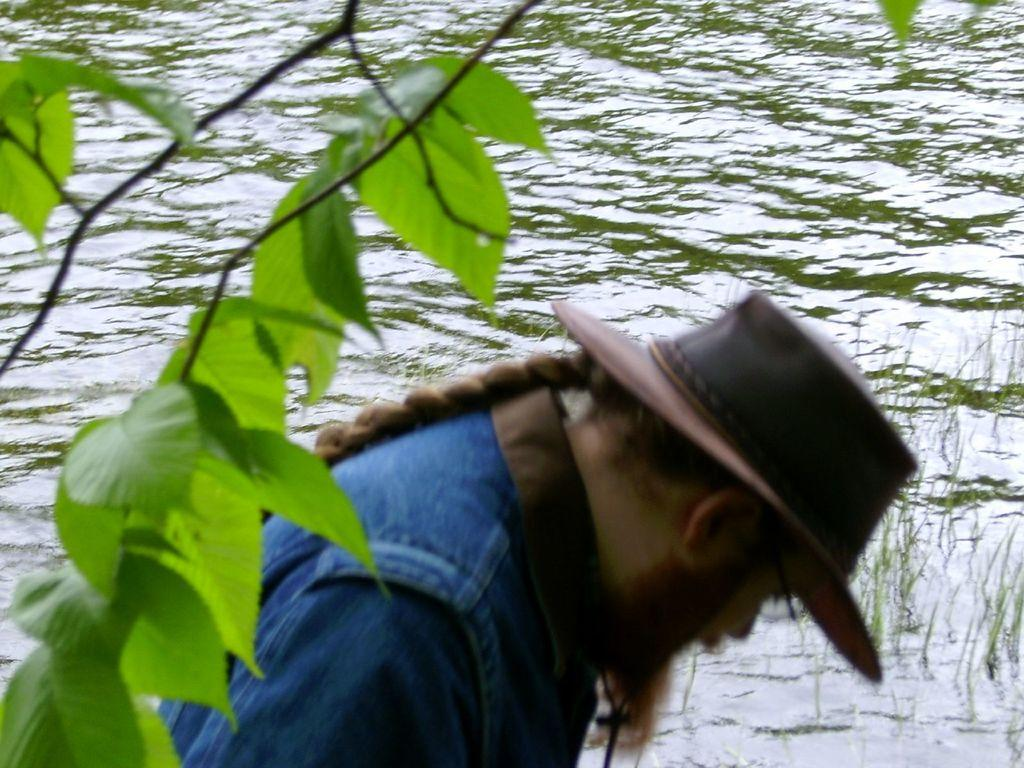What is the person in the image doing? The person is standing beside the water in the image. What else can be seen in the image besides the person? There is a branch of a tree in the image. What type of design can be seen on the map in the image? There is no map present in the image, so it is not possible to answer that question. 